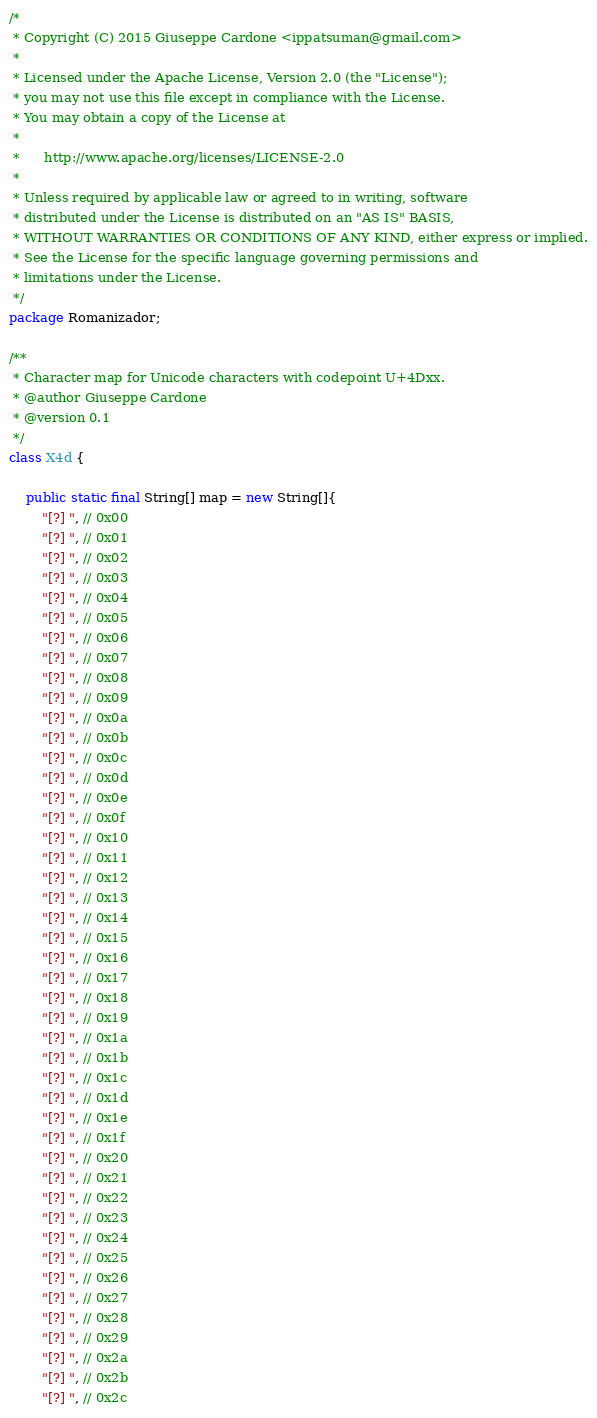<code> <loc_0><loc_0><loc_500><loc_500><_Java_>/*
 * Copyright (C) 2015 Giuseppe Cardone <ippatsuman@gmail.com>
 *
 * Licensed under the Apache License, Version 2.0 (the "License");
 * you may not use this file except in compliance with the License.
 * You may obtain a copy of the License at
 *
 *      http://www.apache.org/licenses/LICENSE-2.0
 *
 * Unless required by applicable law or agreed to in writing, software
 * distributed under the License is distributed on an "AS IS" BASIS,
 * WITHOUT WARRANTIES OR CONDITIONS OF ANY KIND, either express or implied.
 * See the License for the specific language governing permissions and
 * limitations under the License.
 */
package Romanizador;

/**
 * Character map for Unicode characters with codepoint U+4Dxx.
 * @author Giuseppe Cardone
 * @version 0.1
 */
class X4d {

    public static final String[] map = new String[]{
        "[?] ", // 0x00
        "[?] ", // 0x01
        "[?] ", // 0x02
        "[?] ", // 0x03
        "[?] ", // 0x04
        "[?] ", // 0x05
        "[?] ", // 0x06
        "[?] ", // 0x07
        "[?] ", // 0x08
        "[?] ", // 0x09
        "[?] ", // 0x0a
        "[?] ", // 0x0b
        "[?] ", // 0x0c
        "[?] ", // 0x0d
        "[?] ", // 0x0e
        "[?] ", // 0x0f
        "[?] ", // 0x10
        "[?] ", // 0x11
        "[?] ", // 0x12
        "[?] ", // 0x13
        "[?] ", // 0x14
        "[?] ", // 0x15
        "[?] ", // 0x16
        "[?] ", // 0x17
        "[?] ", // 0x18
        "[?] ", // 0x19
        "[?] ", // 0x1a
        "[?] ", // 0x1b
        "[?] ", // 0x1c
        "[?] ", // 0x1d
        "[?] ", // 0x1e
        "[?] ", // 0x1f
        "[?] ", // 0x20
        "[?] ", // 0x21
        "[?] ", // 0x22
        "[?] ", // 0x23
        "[?] ", // 0x24
        "[?] ", // 0x25
        "[?] ", // 0x26
        "[?] ", // 0x27
        "[?] ", // 0x28
        "[?] ", // 0x29
        "[?] ", // 0x2a
        "[?] ", // 0x2b
        "[?] ", // 0x2c</code> 